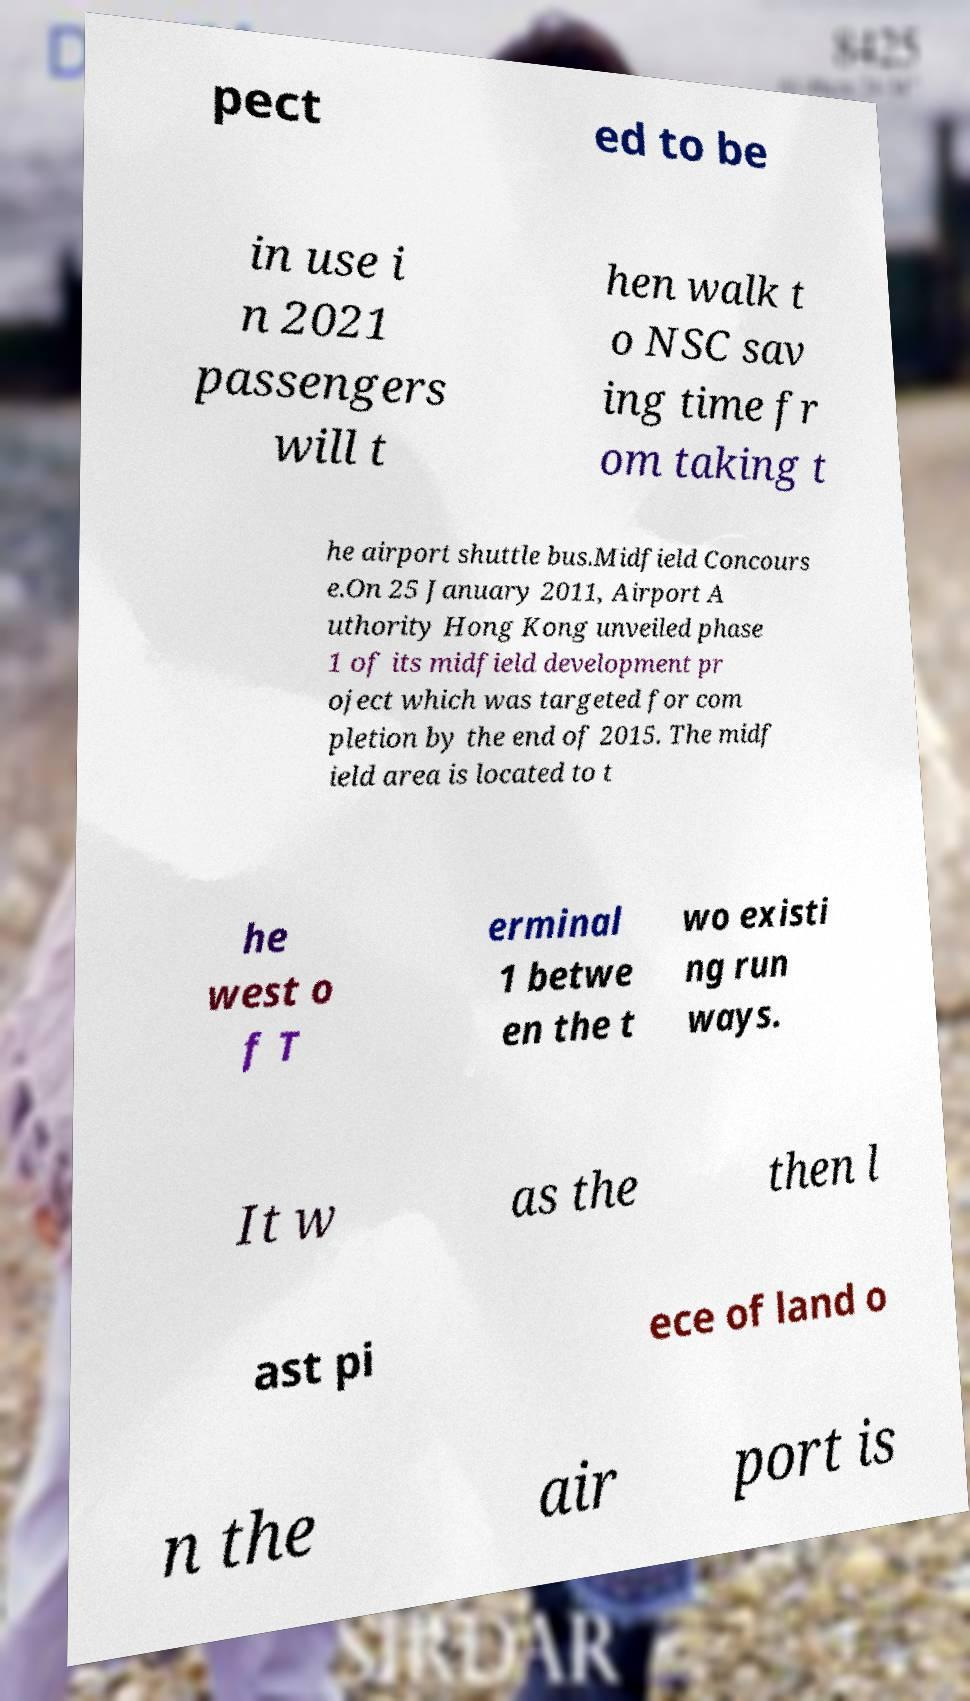Please read and relay the text visible in this image. What does it say? pect ed to be in use i n 2021 passengers will t hen walk t o NSC sav ing time fr om taking t he airport shuttle bus.Midfield Concours e.On 25 January 2011, Airport A uthority Hong Kong unveiled phase 1 of its midfield development pr oject which was targeted for com pletion by the end of 2015. The midf ield area is located to t he west o f T erminal 1 betwe en the t wo existi ng run ways. It w as the then l ast pi ece of land o n the air port is 